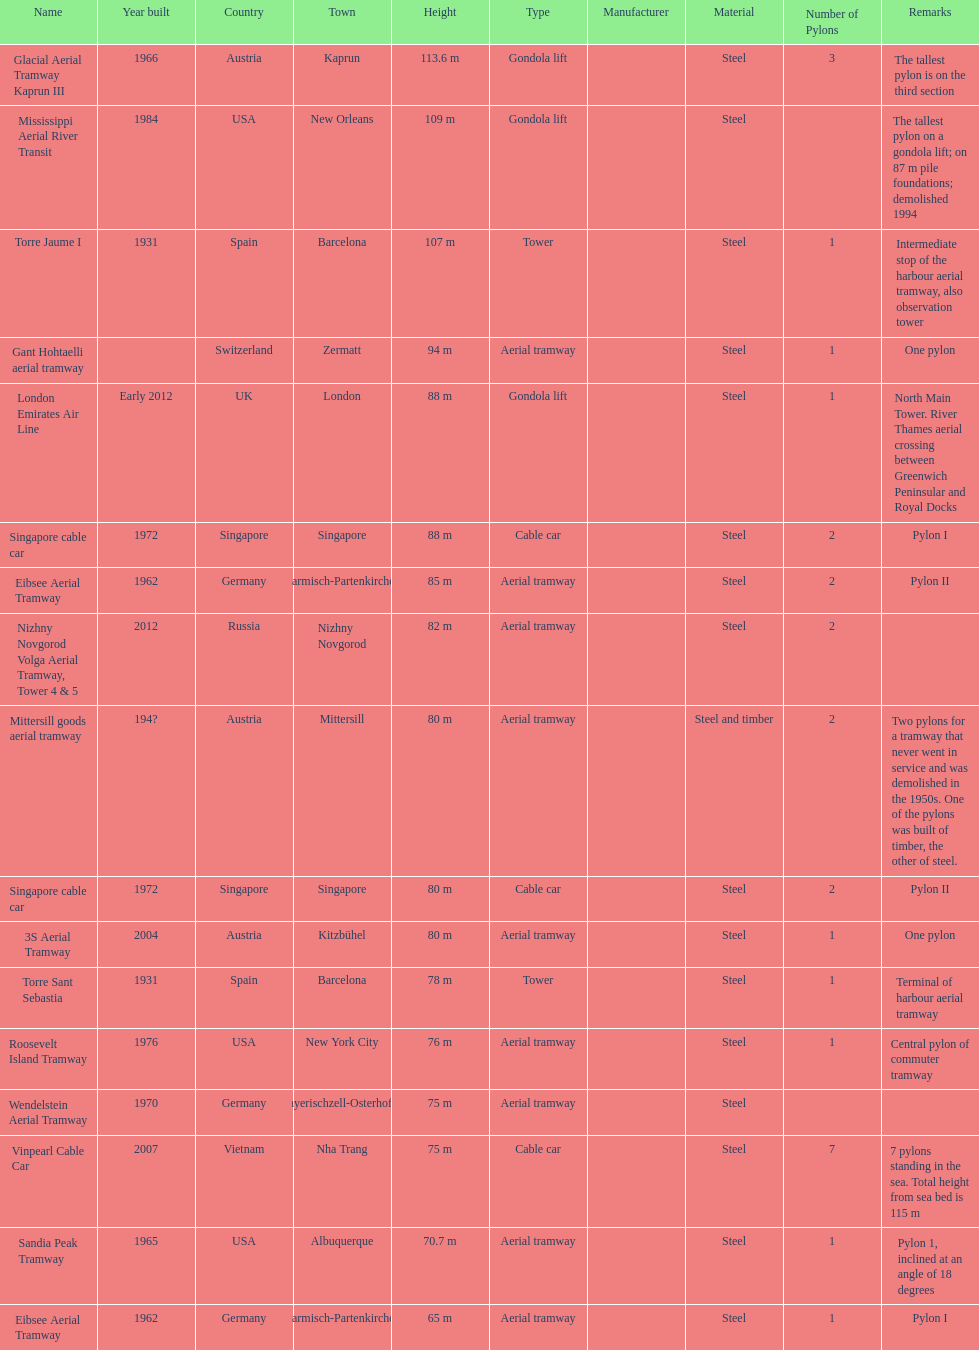The london emirates air line pylon has the same height as which pylon? Singapore cable car. 